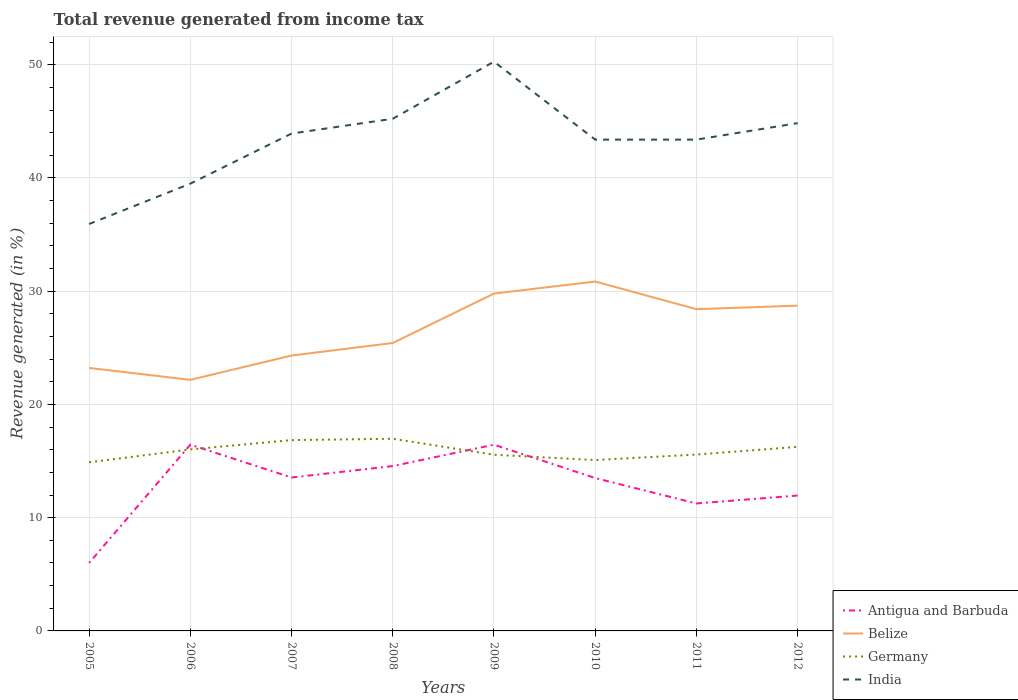How many different coloured lines are there?
Offer a terse response. 4. Does the line corresponding to India intersect with the line corresponding to Belize?
Provide a short and direct response. No. Across all years, what is the maximum total revenue generated in India?
Give a very brief answer. 35.93. In which year was the total revenue generated in Belize maximum?
Keep it short and to the point. 2006. What is the total total revenue generated in Antigua and Barbuda in the graph?
Your answer should be very brief. 2.29. What is the difference between the highest and the second highest total revenue generated in India?
Give a very brief answer. 14.34. What is the difference between the highest and the lowest total revenue generated in Antigua and Barbuda?
Offer a terse response. 5. How many lines are there?
Give a very brief answer. 4. How many years are there in the graph?
Ensure brevity in your answer.  8. Are the values on the major ticks of Y-axis written in scientific E-notation?
Give a very brief answer. No. Does the graph contain grids?
Your answer should be very brief. Yes. How many legend labels are there?
Give a very brief answer. 4. How are the legend labels stacked?
Offer a very short reply. Vertical. What is the title of the graph?
Make the answer very short. Total revenue generated from income tax. What is the label or title of the X-axis?
Provide a short and direct response. Years. What is the label or title of the Y-axis?
Offer a very short reply. Revenue generated (in %). What is the Revenue generated (in %) of Antigua and Barbuda in 2005?
Offer a terse response. 6.01. What is the Revenue generated (in %) in Belize in 2005?
Keep it short and to the point. 23.22. What is the Revenue generated (in %) in Germany in 2005?
Make the answer very short. 14.89. What is the Revenue generated (in %) of India in 2005?
Your answer should be compact. 35.93. What is the Revenue generated (in %) in Antigua and Barbuda in 2006?
Keep it short and to the point. 16.45. What is the Revenue generated (in %) in Belize in 2006?
Provide a short and direct response. 22.17. What is the Revenue generated (in %) in Germany in 2006?
Keep it short and to the point. 16.03. What is the Revenue generated (in %) in India in 2006?
Offer a terse response. 39.5. What is the Revenue generated (in %) in Antigua and Barbuda in 2007?
Your response must be concise. 13.55. What is the Revenue generated (in %) of Belize in 2007?
Offer a very short reply. 24.32. What is the Revenue generated (in %) in Germany in 2007?
Your response must be concise. 16.85. What is the Revenue generated (in %) of India in 2007?
Offer a very short reply. 43.92. What is the Revenue generated (in %) of Antigua and Barbuda in 2008?
Your answer should be compact. 14.56. What is the Revenue generated (in %) in Belize in 2008?
Offer a terse response. 25.43. What is the Revenue generated (in %) in Germany in 2008?
Make the answer very short. 16.97. What is the Revenue generated (in %) in India in 2008?
Keep it short and to the point. 45.23. What is the Revenue generated (in %) in Antigua and Barbuda in 2009?
Ensure brevity in your answer.  16.45. What is the Revenue generated (in %) of Belize in 2009?
Offer a very short reply. 29.79. What is the Revenue generated (in %) in Germany in 2009?
Your response must be concise. 15.56. What is the Revenue generated (in %) in India in 2009?
Ensure brevity in your answer.  50.27. What is the Revenue generated (in %) in Antigua and Barbuda in 2010?
Your answer should be compact. 13.5. What is the Revenue generated (in %) in Belize in 2010?
Make the answer very short. 30.85. What is the Revenue generated (in %) in Germany in 2010?
Your answer should be compact. 15.09. What is the Revenue generated (in %) in India in 2010?
Your answer should be compact. 43.38. What is the Revenue generated (in %) in Antigua and Barbuda in 2011?
Your answer should be very brief. 11.26. What is the Revenue generated (in %) in Belize in 2011?
Ensure brevity in your answer.  28.41. What is the Revenue generated (in %) of Germany in 2011?
Make the answer very short. 15.57. What is the Revenue generated (in %) in India in 2011?
Keep it short and to the point. 43.38. What is the Revenue generated (in %) of Antigua and Barbuda in 2012?
Your answer should be compact. 11.95. What is the Revenue generated (in %) of Belize in 2012?
Provide a succinct answer. 28.72. What is the Revenue generated (in %) in Germany in 2012?
Provide a succinct answer. 16.25. What is the Revenue generated (in %) in India in 2012?
Your response must be concise. 44.84. Across all years, what is the maximum Revenue generated (in %) of Antigua and Barbuda?
Provide a succinct answer. 16.45. Across all years, what is the maximum Revenue generated (in %) in Belize?
Ensure brevity in your answer.  30.85. Across all years, what is the maximum Revenue generated (in %) in Germany?
Offer a terse response. 16.97. Across all years, what is the maximum Revenue generated (in %) in India?
Provide a succinct answer. 50.27. Across all years, what is the minimum Revenue generated (in %) in Antigua and Barbuda?
Provide a short and direct response. 6.01. Across all years, what is the minimum Revenue generated (in %) in Belize?
Provide a succinct answer. 22.17. Across all years, what is the minimum Revenue generated (in %) of Germany?
Make the answer very short. 14.89. Across all years, what is the minimum Revenue generated (in %) of India?
Make the answer very short. 35.93. What is the total Revenue generated (in %) in Antigua and Barbuda in the graph?
Your response must be concise. 103.71. What is the total Revenue generated (in %) in Belize in the graph?
Make the answer very short. 212.92. What is the total Revenue generated (in %) of Germany in the graph?
Provide a succinct answer. 127.21. What is the total Revenue generated (in %) of India in the graph?
Ensure brevity in your answer.  346.46. What is the difference between the Revenue generated (in %) of Antigua and Barbuda in 2005 and that in 2006?
Your answer should be very brief. -10.44. What is the difference between the Revenue generated (in %) of Belize in 2005 and that in 2006?
Provide a succinct answer. 1.05. What is the difference between the Revenue generated (in %) in Germany in 2005 and that in 2006?
Ensure brevity in your answer.  -1.13. What is the difference between the Revenue generated (in %) of India in 2005 and that in 2006?
Provide a short and direct response. -3.56. What is the difference between the Revenue generated (in %) of Antigua and Barbuda in 2005 and that in 2007?
Your answer should be compact. -7.54. What is the difference between the Revenue generated (in %) in Belize in 2005 and that in 2007?
Your answer should be very brief. -1.1. What is the difference between the Revenue generated (in %) in Germany in 2005 and that in 2007?
Offer a terse response. -1.96. What is the difference between the Revenue generated (in %) of India in 2005 and that in 2007?
Offer a terse response. -7.99. What is the difference between the Revenue generated (in %) of Antigua and Barbuda in 2005 and that in 2008?
Ensure brevity in your answer.  -8.55. What is the difference between the Revenue generated (in %) of Belize in 2005 and that in 2008?
Your answer should be very brief. -2.21. What is the difference between the Revenue generated (in %) of Germany in 2005 and that in 2008?
Your answer should be very brief. -2.08. What is the difference between the Revenue generated (in %) in India in 2005 and that in 2008?
Give a very brief answer. -9.29. What is the difference between the Revenue generated (in %) in Antigua and Barbuda in 2005 and that in 2009?
Make the answer very short. -10.44. What is the difference between the Revenue generated (in %) in Belize in 2005 and that in 2009?
Keep it short and to the point. -6.57. What is the difference between the Revenue generated (in %) of Germany in 2005 and that in 2009?
Provide a succinct answer. -0.66. What is the difference between the Revenue generated (in %) of India in 2005 and that in 2009?
Provide a short and direct response. -14.34. What is the difference between the Revenue generated (in %) of Antigua and Barbuda in 2005 and that in 2010?
Offer a terse response. -7.49. What is the difference between the Revenue generated (in %) of Belize in 2005 and that in 2010?
Offer a very short reply. -7.63. What is the difference between the Revenue generated (in %) in Germany in 2005 and that in 2010?
Give a very brief answer. -0.2. What is the difference between the Revenue generated (in %) in India in 2005 and that in 2010?
Offer a terse response. -7.45. What is the difference between the Revenue generated (in %) of Antigua and Barbuda in 2005 and that in 2011?
Provide a short and direct response. -5.25. What is the difference between the Revenue generated (in %) of Belize in 2005 and that in 2011?
Your answer should be very brief. -5.19. What is the difference between the Revenue generated (in %) of Germany in 2005 and that in 2011?
Your response must be concise. -0.68. What is the difference between the Revenue generated (in %) of India in 2005 and that in 2011?
Ensure brevity in your answer.  -7.45. What is the difference between the Revenue generated (in %) in Antigua and Barbuda in 2005 and that in 2012?
Offer a very short reply. -5.95. What is the difference between the Revenue generated (in %) in Belize in 2005 and that in 2012?
Ensure brevity in your answer.  -5.5. What is the difference between the Revenue generated (in %) in Germany in 2005 and that in 2012?
Offer a very short reply. -1.36. What is the difference between the Revenue generated (in %) in India in 2005 and that in 2012?
Your answer should be compact. -8.91. What is the difference between the Revenue generated (in %) of Antigua and Barbuda in 2006 and that in 2007?
Keep it short and to the point. 2.9. What is the difference between the Revenue generated (in %) of Belize in 2006 and that in 2007?
Ensure brevity in your answer.  -2.15. What is the difference between the Revenue generated (in %) in Germany in 2006 and that in 2007?
Ensure brevity in your answer.  -0.83. What is the difference between the Revenue generated (in %) of India in 2006 and that in 2007?
Keep it short and to the point. -4.42. What is the difference between the Revenue generated (in %) in Antigua and Barbuda in 2006 and that in 2008?
Your answer should be very brief. 1.89. What is the difference between the Revenue generated (in %) of Belize in 2006 and that in 2008?
Give a very brief answer. -3.26. What is the difference between the Revenue generated (in %) in Germany in 2006 and that in 2008?
Offer a very short reply. -0.94. What is the difference between the Revenue generated (in %) of India in 2006 and that in 2008?
Your answer should be very brief. -5.73. What is the difference between the Revenue generated (in %) of Antigua and Barbuda in 2006 and that in 2009?
Keep it short and to the point. 0. What is the difference between the Revenue generated (in %) of Belize in 2006 and that in 2009?
Your answer should be very brief. -7.62. What is the difference between the Revenue generated (in %) in Germany in 2006 and that in 2009?
Your answer should be very brief. 0.47. What is the difference between the Revenue generated (in %) in India in 2006 and that in 2009?
Provide a short and direct response. -10.77. What is the difference between the Revenue generated (in %) of Antigua and Barbuda in 2006 and that in 2010?
Your answer should be very brief. 2.95. What is the difference between the Revenue generated (in %) of Belize in 2006 and that in 2010?
Keep it short and to the point. -8.68. What is the difference between the Revenue generated (in %) of Germany in 2006 and that in 2010?
Make the answer very short. 0.94. What is the difference between the Revenue generated (in %) of India in 2006 and that in 2010?
Your answer should be very brief. -3.89. What is the difference between the Revenue generated (in %) of Antigua and Barbuda in 2006 and that in 2011?
Your answer should be compact. 5.19. What is the difference between the Revenue generated (in %) in Belize in 2006 and that in 2011?
Give a very brief answer. -6.24. What is the difference between the Revenue generated (in %) in Germany in 2006 and that in 2011?
Provide a succinct answer. 0.45. What is the difference between the Revenue generated (in %) of India in 2006 and that in 2011?
Provide a succinct answer. -3.89. What is the difference between the Revenue generated (in %) of Antigua and Barbuda in 2006 and that in 2012?
Ensure brevity in your answer.  4.49. What is the difference between the Revenue generated (in %) of Belize in 2006 and that in 2012?
Make the answer very short. -6.55. What is the difference between the Revenue generated (in %) of Germany in 2006 and that in 2012?
Your response must be concise. -0.23. What is the difference between the Revenue generated (in %) in India in 2006 and that in 2012?
Keep it short and to the point. -5.34. What is the difference between the Revenue generated (in %) of Antigua and Barbuda in 2007 and that in 2008?
Your response must be concise. -1.01. What is the difference between the Revenue generated (in %) of Belize in 2007 and that in 2008?
Keep it short and to the point. -1.11. What is the difference between the Revenue generated (in %) in Germany in 2007 and that in 2008?
Your answer should be very brief. -0.12. What is the difference between the Revenue generated (in %) of India in 2007 and that in 2008?
Your answer should be compact. -1.31. What is the difference between the Revenue generated (in %) of Antigua and Barbuda in 2007 and that in 2009?
Make the answer very short. -2.9. What is the difference between the Revenue generated (in %) in Belize in 2007 and that in 2009?
Your response must be concise. -5.47. What is the difference between the Revenue generated (in %) of Germany in 2007 and that in 2009?
Keep it short and to the point. 1.29. What is the difference between the Revenue generated (in %) of India in 2007 and that in 2009?
Make the answer very short. -6.35. What is the difference between the Revenue generated (in %) of Antigua and Barbuda in 2007 and that in 2010?
Offer a very short reply. 0.05. What is the difference between the Revenue generated (in %) of Belize in 2007 and that in 2010?
Offer a terse response. -6.53. What is the difference between the Revenue generated (in %) in Germany in 2007 and that in 2010?
Make the answer very short. 1.76. What is the difference between the Revenue generated (in %) of India in 2007 and that in 2010?
Provide a succinct answer. 0.54. What is the difference between the Revenue generated (in %) in Antigua and Barbuda in 2007 and that in 2011?
Provide a succinct answer. 2.29. What is the difference between the Revenue generated (in %) of Belize in 2007 and that in 2011?
Your response must be concise. -4.09. What is the difference between the Revenue generated (in %) in Germany in 2007 and that in 2011?
Your response must be concise. 1.28. What is the difference between the Revenue generated (in %) of India in 2007 and that in 2011?
Your answer should be very brief. 0.54. What is the difference between the Revenue generated (in %) of Antigua and Barbuda in 2007 and that in 2012?
Your answer should be compact. 1.59. What is the difference between the Revenue generated (in %) in Belize in 2007 and that in 2012?
Give a very brief answer. -4.41. What is the difference between the Revenue generated (in %) of Germany in 2007 and that in 2012?
Provide a succinct answer. 0.6. What is the difference between the Revenue generated (in %) of India in 2007 and that in 2012?
Provide a succinct answer. -0.92. What is the difference between the Revenue generated (in %) of Antigua and Barbuda in 2008 and that in 2009?
Provide a short and direct response. -1.89. What is the difference between the Revenue generated (in %) of Belize in 2008 and that in 2009?
Make the answer very short. -4.36. What is the difference between the Revenue generated (in %) of Germany in 2008 and that in 2009?
Provide a short and direct response. 1.41. What is the difference between the Revenue generated (in %) in India in 2008 and that in 2009?
Offer a terse response. -5.04. What is the difference between the Revenue generated (in %) of Antigua and Barbuda in 2008 and that in 2010?
Your response must be concise. 1.06. What is the difference between the Revenue generated (in %) of Belize in 2008 and that in 2010?
Ensure brevity in your answer.  -5.43. What is the difference between the Revenue generated (in %) in Germany in 2008 and that in 2010?
Offer a very short reply. 1.88. What is the difference between the Revenue generated (in %) in India in 2008 and that in 2010?
Provide a short and direct response. 1.84. What is the difference between the Revenue generated (in %) in Antigua and Barbuda in 2008 and that in 2011?
Your answer should be very brief. 3.3. What is the difference between the Revenue generated (in %) of Belize in 2008 and that in 2011?
Offer a terse response. -2.98. What is the difference between the Revenue generated (in %) of Germany in 2008 and that in 2011?
Your answer should be compact. 1.4. What is the difference between the Revenue generated (in %) in India in 2008 and that in 2011?
Your answer should be very brief. 1.84. What is the difference between the Revenue generated (in %) in Antigua and Barbuda in 2008 and that in 2012?
Your answer should be very brief. 2.6. What is the difference between the Revenue generated (in %) of Belize in 2008 and that in 2012?
Offer a very short reply. -3.3. What is the difference between the Revenue generated (in %) of Germany in 2008 and that in 2012?
Your response must be concise. 0.72. What is the difference between the Revenue generated (in %) of India in 2008 and that in 2012?
Keep it short and to the point. 0.39. What is the difference between the Revenue generated (in %) in Antigua and Barbuda in 2009 and that in 2010?
Offer a very short reply. 2.95. What is the difference between the Revenue generated (in %) in Belize in 2009 and that in 2010?
Your response must be concise. -1.06. What is the difference between the Revenue generated (in %) of Germany in 2009 and that in 2010?
Your answer should be very brief. 0.47. What is the difference between the Revenue generated (in %) in India in 2009 and that in 2010?
Keep it short and to the point. 6.89. What is the difference between the Revenue generated (in %) of Antigua and Barbuda in 2009 and that in 2011?
Ensure brevity in your answer.  5.19. What is the difference between the Revenue generated (in %) in Belize in 2009 and that in 2011?
Provide a short and direct response. 1.38. What is the difference between the Revenue generated (in %) in Germany in 2009 and that in 2011?
Provide a succinct answer. -0.02. What is the difference between the Revenue generated (in %) in India in 2009 and that in 2011?
Give a very brief answer. 6.89. What is the difference between the Revenue generated (in %) in Antigua and Barbuda in 2009 and that in 2012?
Provide a succinct answer. 4.49. What is the difference between the Revenue generated (in %) in Belize in 2009 and that in 2012?
Make the answer very short. 1.07. What is the difference between the Revenue generated (in %) in Germany in 2009 and that in 2012?
Give a very brief answer. -0.7. What is the difference between the Revenue generated (in %) of India in 2009 and that in 2012?
Provide a succinct answer. 5.43. What is the difference between the Revenue generated (in %) of Antigua and Barbuda in 2010 and that in 2011?
Offer a very short reply. 2.24. What is the difference between the Revenue generated (in %) of Belize in 2010 and that in 2011?
Your response must be concise. 2.44. What is the difference between the Revenue generated (in %) of Germany in 2010 and that in 2011?
Make the answer very short. -0.48. What is the difference between the Revenue generated (in %) of India in 2010 and that in 2011?
Offer a terse response. 0. What is the difference between the Revenue generated (in %) of Antigua and Barbuda in 2010 and that in 2012?
Offer a terse response. 1.54. What is the difference between the Revenue generated (in %) of Belize in 2010 and that in 2012?
Provide a short and direct response. 2.13. What is the difference between the Revenue generated (in %) of Germany in 2010 and that in 2012?
Your answer should be very brief. -1.16. What is the difference between the Revenue generated (in %) of India in 2010 and that in 2012?
Keep it short and to the point. -1.45. What is the difference between the Revenue generated (in %) in Antigua and Barbuda in 2011 and that in 2012?
Make the answer very short. -0.7. What is the difference between the Revenue generated (in %) in Belize in 2011 and that in 2012?
Give a very brief answer. -0.31. What is the difference between the Revenue generated (in %) of Germany in 2011 and that in 2012?
Make the answer very short. -0.68. What is the difference between the Revenue generated (in %) in India in 2011 and that in 2012?
Provide a short and direct response. -1.45. What is the difference between the Revenue generated (in %) in Antigua and Barbuda in 2005 and the Revenue generated (in %) in Belize in 2006?
Offer a very short reply. -16.17. What is the difference between the Revenue generated (in %) in Antigua and Barbuda in 2005 and the Revenue generated (in %) in Germany in 2006?
Give a very brief answer. -10.02. What is the difference between the Revenue generated (in %) in Antigua and Barbuda in 2005 and the Revenue generated (in %) in India in 2006?
Provide a short and direct response. -33.49. What is the difference between the Revenue generated (in %) of Belize in 2005 and the Revenue generated (in %) of Germany in 2006?
Your answer should be very brief. 7.2. What is the difference between the Revenue generated (in %) of Belize in 2005 and the Revenue generated (in %) of India in 2006?
Your answer should be compact. -16.28. What is the difference between the Revenue generated (in %) in Germany in 2005 and the Revenue generated (in %) in India in 2006?
Give a very brief answer. -24.61. What is the difference between the Revenue generated (in %) of Antigua and Barbuda in 2005 and the Revenue generated (in %) of Belize in 2007?
Offer a terse response. -18.31. What is the difference between the Revenue generated (in %) of Antigua and Barbuda in 2005 and the Revenue generated (in %) of Germany in 2007?
Provide a short and direct response. -10.85. What is the difference between the Revenue generated (in %) of Antigua and Barbuda in 2005 and the Revenue generated (in %) of India in 2007?
Keep it short and to the point. -37.92. What is the difference between the Revenue generated (in %) of Belize in 2005 and the Revenue generated (in %) of Germany in 2007?
Ensure brevity in your answer.  6.37. What is the difference between the Revenue generated (in %) in Belize in 2005 and the Revenue generated (in %) in India in 2007?
Provide a short and direct response. -20.7. What is the difference between the Revenue generated (in %) of Germany in 2005 and the Revenue generated (in %) of India in 2007?
Provide a short and direct response. -29.03. What is the difference between the Revenue generated (in %) of Antigua and Barbuda in 2005 and the Revenue generated (in %) of Belize in 2008?
Give a very brief answer. -19.42. What is the difference between the Revenue generated (in %) in Antigua and Barbuda in 2005 and the Revenue generated (in %) in Germany in 2008?
Provide a short and direct response. -10.96. What is the difference between the Revenue generated (in %) in Antigua and Barbuda in 2005 and the Revenue generated (in %) in India in 2008?
Offer a terse response. -39.22. What is the difference between the Revenue generated (in %) in Belize in 2005 and the Revenue generated (in %) in Germany in 2008?
Your response must be concise. 6.25. What is the difference between the Revenue generated (in %) of Belize in 2005 and the Revenue generated (in %) of India in 2008?
Keep it short and to the point. -22.01. What is the difference between the Revenue generated (in %) in Germany in 2005 and the Revenue generated (in %) in India in 2008?
Your response must be concise. -30.34. What is the difference between the Revenue generated (in %) in Antigua and Barbuda in 2005 and the Revenue generated (in %) in Belize in 2009?
Ensure brevity in your answer.  -23.79. What is the difference between the Revenue generated (in %) of Antigua and Barbuda in 2005 and the Revenue generated (in %) of Germany in 2009?
Your answer should be very brief. -9.55. What is the difference between the Revenue generated (in %) in Antigua and Barbuda in 2005 and the Revenue generated (in %) in India in 2009?
Give a very brief answer. -44.27. What is the difference between the Revenue generated (in %) in Belize in 2005 and the Revenue generated (in %) in Germany in 2009?
Your response must be concise. 7.66. What is the difference between the Revenue generated (in %) of Belize in 2005 and the Revenue generated (in %) of India in 2009?
Ensure brevity in your answer.  -27.05. What is the difference between the Revenue generated (in %) of Germany in 2005 and the Revenue generated (in %) of India in 2009?
Provide a short and direct response. -35.38. What is the difference between the Revenue generated (in %) in Antigua and Barbuda in 2005 and the Revenue generated (in %) in Belize in 2010?
Offer a very short reply. -24.85. What is the difference between the Revenue generated (in %) in Antigua and Barbuda in 2005 and the Revenue generated (in %) in Germany in 2010?
Offer a very short reply. -9.08. What is the difference between the Revenue generated (in %) of Antigua and Barbuda in 2005 and the Revenue generated (in %) of India in 2010?
Make the answer very short. -37.38. What is the difference between the Revenue generated (in %) in Belize in 2005 and the Revenue generated (in %) in Germany in 2010?
Offer a very short reply. 8.13. What is the difference between the Revenue generated (in %) of Belize in 2005 and the Revenue generated (in %) of India in 2010?
Ensure brevity in your answer.  -20.16. What is the difference between the Revenue generated (in %) of Germany in 2005 and the Revenue generated (in %) of India in 2010?
Offer a terse response. -28.49. What is the difference between the Revenue generated (in %) in Antigua and Barbuda in 2005 and the Revenue generated (in %) in Belize in 2011?
Ensure brevity in your answer.  -22.41. What is the difference between the Revenue generated (in %) in Antigua and Barbuda in 2005 and the Revenue generated (in %) in Germany in 2011?
Keep it short and to the point. -9.57. What is the difference between the Revenue generated (in %) in Antigua and Barbuda in 2005 and the Revenue generated (in %) in India in 2011?
Give a very brief answer. -37.38. What is the difference between the Revenue generated (in %) of Belize in 2005 and the Revenue generated (in %) of Germany in 2011?
Provide a short and direct response. 7.65. What is the difference between the Revenue generated (in %) of Belize in 2005 and the Revenue generated (in %) of India in 2011?
Make the answer very short. -20.16. What is the difference between the Revenue generated (in %) of Germany in 2005 and the Revenue generated (in %) of India in 2011?
Provide a short and direct response. -28.49. What is the difference between the Revenue generated (in %) of Antigua and Barbuda in 2005 and the Revenue generated (in %) of Belize in 2012?
Provide a short and direct response. -22.72. What is the difference between the Revenue generated (in %) in Antigua and Barbuda in 2005 and the Revenue generated (in %) in Germany in 2012?
Offer a terse response. -10.25. What is the difference between the Revenue generated (in %) of Antigua and Barbuda in 2005 and the Revenue generated (in %) of India in 2012?
Your response must be concise. -38.83. What is the difference between the Revenue generated (in %) of Belize in 2005 and the Revenue generated (in %) of Germany in 2012?
Provide a short and direct response. 6.97. What is the difference between the Revenue generated (in %) of Belize in 2005 and the Revenue generated (in %) of India in 2012?
Make the answer very short. -21.62. What is the difference between the Revenue generated (in %) in Germany in 2005 and the Revenue generated (in %) in India in 2012?
Your response must be concise. -29.95. What is the difference between the Revenue generated (in %) of Antigua and Barbuda in 2006 and the Revenue generated (in %) of Belize in 2007?
Your response must be concise. -7.87. What is the difference between the Revenue generated (in %) in Antigua and Barbuda in 2006 and the Revenue generated (in %) in Germany in 2007?
Make the answer very short. -0.4. What is the difference between the Revenue generated (in %) of Antigua and Barbuda in 2006 and the Revenue generated (in %) of India in 2007?
Make the answer very short. -27.47. What is the difference between the Revenue generated (in %) in Belize in 2006 and the Revenue generated (in %) in Germany in 2007?
Make the answer very short. 5.32. What is the difference between the Revenue generated (in %) in Belize in 2006 and the Revenue generated (in %) in India in 2007?
Provide a short and direct response. -21.75. What is the difference between the Revenue generated (in %) of Germany in 2006 and the Revenue generated (in %) of India in 2007?
Provide a succinct answer. -27.9. What is the difference between the Revenue generated (in %) of Antigua and Barbuda in 2006 and the Revenue generated (in %) of Belize in 2008?
Offer a terse response. -8.98. What is the difference between the Revenue generated (in %) of Antigua and Barbuda in 2006 and the Revenue generated (in %) of Germany in 2008?
Ensure brevity in your answer.  -0.52. What is the difference between the Revenue generated (in %) in Antigua and Barbuda in 2006 and the Revenue generated (in %) in India in 2008?
Offer a terse response. -28.78. What is the difference between the Revenue generated (in %) of Belize in 2006 and the Revenue generated (in %) of Germany in 2008?
Give a very brief answer. 5.2. What is the difference between the Revenue generated (in %) in Belize in 2006 and the Revenue generated (in %) in India in 2008?
Your response must be concise. -23.06. What is the difference between the Revenue generated (in %) in Germany in 2006 and the Revenue generated (in %) in India in 2008?
Your response must be concise. -29.2. What is the difference between the Revenue generated (in %) of Antigua and Barbuda in 2006 and the Revenue generated (in %) of Belize in 2009?
Ensure brevity in your answer.  -13.34. What is the difference between the Revenue generated (in %) of Antigua and Barbuda in 2006 and the Revenue generated (in %) of Germany in 2009?
Give a very brief answer. 0.89. What is the difference between the Revenue generated (in %) in Antigua and Barbuda in 2006 and the Revenue generated (in %) in India in 2009?
Provide a succinct answer. -33.82. What is the difference between the Revenue generated (in %) of Belize in 2006 and the Revenue generated (in %) of Germany in 2009?
Provide a short and direct response. 6.61. What is the difference between the Revenue generated (in %) in Belize in 2006 and the Revenue generated (in %) in India in 2009?
Offer a very short reply. -28.1. What is the difference between the Revenue generated (in %) in Germany in 2006 and the Revenue generated (in %) in India in 2009?
Offer a very short reply. -34.25. What is the difference between the Revenue generated (in %) in Antigua and Barbuda in 2006 and the Revenue generated (in %) in Belize in 2010?
Make the answer very short. -14.41. What is the difference between the Revenue generated (in %) of Antigua and Barbuda in 2006 and the Revenue generated (in %) of Germany in 2010?
Your answer should be compact. 1.36. What is the difference between the Revenue generated (in %) of Antigua and Barbuda in 2006 and the Revenue generated (in %) of India in 2010?
Provide a succinct answer. -26.94. What is the difference between the Revenue generated (in %) in Belize in 2006 and the Revenue generated (in %) in Germany in 2010?
Ensure brevity in your answer.  7.08. What is the difference between the Revenue generated (in %) of Belize in 2006 and the Revenue generated (in %) of India in 2010?
Provide a succinct answer. -21.21. What is the difference between the Revenue generated (in %) in Germany in 2006 and the Revenue generated (in %) in India in 2010?
Your answer should be very brief. -27.36. What is the difference between the Revenue generated (in %) in Antigua and Barbuda in 2006 and the Revenue generated (in %) in Belize in 2011?
Give a very brief answer. -11.96. What is the difference between the Revenue generated (in %) in Antigua and Barbuda in 2006 and the Revenue generated (in %) in Germany in 2011?
Make the answer very short. 0.87. What is the difference between the Revenue generated (in %) in Antigua and Barbuda in 2006 and the Revenue generated (in %) in India in 2011?
Your answer should be very brief. -26.94. What is the difference between the Revenue generated (in %) of Belize in 2006 and the Revenue generated (in %) of Germany in 2011?
Provide a succinct answer. 6.6. What is the difference between the Revenue generated (in %) of Belize in 2006 and the Revenue generated (in %) of India in 2011?
Offer a very short reply. -21.21. What is the difference between the Revenue generated (in %) in Germany in 2006 and the Revenue generated (in %) in India in 2011?
Ensure brevity in your answer.  -27.36. What is the difference between the Revenue generated (in %) of Antigua and Barbuda in 2006 and the Revenue generated (in %) of Belize in 2012?
Your answer should be very brief. -12.28. What is the difference between the Revenue generated (in %) of Antigua and Barbuda in 2006 and the Revenue generated (in %) of Germany in 2012?
Give a very brief answer. 0.19. What is the difference between the Revenue generated (in %) of Antigua and Barbuda in 2006 and the Revenue generated (in %) of India in 2012?
Offer a very short reply. -28.39. What is the difference between the Revenue generated (in %) of Belize in 2006 and the Revenue generated (in %) of Germany in 2012?
Your response must be concise. 5.92. What is the difference between the Revenue generated (in %) of Belize in 2006 and the Revenue generated (in %) of India in 2012?
Keep it short and to the point. -22.67. What is the difference between the Revenue generated (in %) in Germany in 2006 and the Revenue generated (in %) in India in 2012?
Your response must be concise. -28.81. What is the difference between the Revenue generated (in %) in Antigua and Barbuda in 2007 and the Revenue generated (in %) in Belize in 2008?
Offer a terse response. -11.88. What is the difference between the Revenue generated (in %) of Antigua and Barbuda in 2007 and the Revenue generated (in %) of Germany in 2008?
Give a very brief answer. -3.42. What is the difference between the Revenue generated (in %) of Antigua and Barbuda in 2007 and the Revenue generated (in %) of India in 2008?
Keep it short and to the point. -31.68. What is the difference between the Revenue generated (in %) in Belize in 2007 and the Revenue generated (in %) in Germany in 2008?
Provide a short and direct response. 7.35. What is the difference between the Revenue generated (in %) of Belize in 2007 and the Revenue generated (in %) of India in 2008?
Offer a terse response. -20.91. What is the difference between the Revenue generated (in %) in Germany in 2007 and the Revenue generated (in %) in India in 2008?
Your answer should be compact. -28.38. What is the difference between the Revenue generated (in %) of Antigua and Barbuda in 2007 and the Revenue generated (in %) of Belize in 2009?
Your answer should be compact. -16.24. What is the difference between the Revenue generated (in %) in Antigua and Barbuda in 2007 and the Revenue generated (in %) in Germany in 2009?
Keep it short and to the point. -2.01. What is the difference between the Revenue generated (in %) of Antigua and Barbuda in 2007 and the Revenue generated (in %) of India in 2009?
Give a very brief answer. -36.72. What is the difference between the Revenue generated (in %) of Belize in 2007 and the Revenue generated (in %) of Germany in 2009?
Your answer should be compact. 8.76. What is the difference between the Revenue generated (in %) of Belize in 2007 and the Revenue generated (in %) of India in 2009?
Your response must be concise. -25.95. What is the difference between the Revenue generated (in %) in Germany in 2007 and the Revenue generated (in %) in India in 2009?
Give a very brief answer. -33.42. What is the difference between the Revenue generated (in %) of Antigua and Barbuda in 2007 and the Revenue generated (in %) of Belize in 2010?
Offer a terse response. -17.3. What is the difference between the Revenue generated (in %) in Antigua and Barbuda in 2007 and the Revenue generated (in %) in Germany in 2010?
Provide a succinct answer. -1.54. What is the difference between the Revenue generated (in %) in Antigua and Barbuda in 2007 and the Revenue generated (in %) in India in 2010?
Provide a succinct answer. -29.84. What is the difference between the Revenue generated (in %) of Belize in 2007 and the Revenue generated (in %) of Germany in 2010?
Offer a terse response. 9.23. What is the difference between the Revenue generated (in %) in Belize in 2007 and the Revenue generated (in %) in India in 2010?
Your answer should be very brief. -19.07. What is the difference between the Revenue generated (in %) of Germany in 2007 and the Revenue generated (in %) of India in 2010?
Make the answer very short. -26.53. What is the difference between the Revenue generated (in %) in Antigua and Barbuda in 2007 and the Revenue generated (in %) in Belize in 2011?
Provide a short and direct response. -14.86. What is the difference between the Revenue generated (in %) of Antigua and Barbuda in 2007 and the Revenue generated (in %) of Germany in 2011?
Make the answer very short. -2.03. What is the difference between the Revenue generated (in %) of Antigua and Barbuda in 2007 and the Revenue generated (in %) of India in 2011?
Keep it short and to the point. -29.84. What is the difference between the Revenue generated (in %) in Belize in 2007 and the Revenue generated (in %) in Germany in 2011?
Provide a succinct answer. 8.74. What is the difference between the Revenue generated (in %) in Belize in 2007 and the Revenue generated (in %) in India in 2011?
Offer a very short reply. -19.07. What is the difference between the Revenue generated (in %) of Germany in 2007 and the Revenue generated (in %) of India in 2011?
Provide a short and direct response. -26.53. What is the difference between the Revenue generated (in %) in Antigua and Barbuda in 2007 and the Revenue generated (in %) in Belize in 2012?
Provide a short and direct response. -15.18. What is the difference between the Revenue generated (in %) of Antigua and Barbuda in 2007 and the Revenue generated (in %) of Germany in 2012?
Provide a succinct answer. -2.7. What is the difference between the Revenue generated (in %) of Antigua and Barbuda in 2007 and the Revenue generated (in %) of India in 2012?
Your response must be concise. -31.29. What is the difference between the Revenue generated (in %) of Belize in 2007 and the Revenue generated (in %) of Germany in 2012?
Offer a very short reply. 8.06. What is the difference between the Revenue generated (in %) of Belize in 2007 and the Revenue generated (in %) of India in 2012?
Offer a very short reply. -20.52. What is the difference between the Revenue generated (in %) in Germany in 2007 and the Revenue generated (in %) in India in 2012?
Provide a short and direct response. -27.99. What is the difference between the Revenue generated (in %) of Antigua and Barbuda in 2008 and the Revenue generated (in %) of Belize in 2009?
Ensure brevity in your answer.  -15.23. What is the difference between the Revenue generated (in %) in Antigua and Barbuda in 2008 and the Revenue generated (in %) in Germany in 2009?
Ensure brevity in your answer.  -1. What is the difference between the Revenue generated (in %) of Antigua and Barbuda in 2008 and the Revenue generated (in %) of India in 2009?
Provide a short and direct response. -35.71. What is the difference between the Revenue generated (in %) in Belize in 2008 and the Revenue generated (in %) in Germany in 2009?
Give a very brief answer. 9.87. What is the difference between the Revenue generated (in %) of Belize in 2008 and the Revenue generated (in %) of India in 2009?
Give a very brief answer. -24.84. What is the difference between the Revenue generated (in %) of Germany in 2008 and the Revenue generated (in %) of India in 2009?
Ensure brevity in your answer.  -33.3. What is the difference between the Revenue generated (in %) in Antigua and Barbuda in 2008 and the Revenue generated (in %) in Belize in 2010?
Your answer should be compact. -16.3. What is the difference between the Revenue generated (in %) of Antigua and Barbuda in 2008 and the Revenue generated (in %) of Germany in 2010?
Your response must be concise. -0.53. What is the difference between the Revenue generated (in %) of Antigua and Barbuda in 2008 and the Revenue generated (in %) of India in 2010?
Your answer should be compact. -28.83. What is the difference between the Revenue generated (in %) of Belize in 2008 and the Revenue generated (in %) of Germany in 2010?
Your answer should be compact. 10.34. What is the difference between the Revenue generated (in %) of Belize in 2008 and the Revenue generated (in %) of India in 2010?
Offer a very short reply. -17.96. What is the difference between the Revenue generated (in %) in Germany in 2008 and the Revenue generated (in %) in India in 2010?
Your answer should be very brief. -26.41. What is the difference between the Revenue generated (in %) of Antigua and Barbuda in 2008 and the Revenue generated (in %) of Belize in 2011?
Offer a terse response. -13.86. What is the difference between the Revenue generated (in %) of Antigua and Barbuda in 2008 and the Revenue generated (in %) of Germany in 2011?
Your answer should be compact. -1.02. What is the difference between the Revenue generated (in %) of Antigua and Barbuda in 2008 and the Revenue generated (in %) of India in 2011?
Offer a terse response. -28.83. What is the difference between the Revenue generated (in %) of Belize in 2008 and the Revenue generated (in %) of Germany in 2011?
Your answer should be compact. 9.85. What is the difference between the Revenue generated (in %) of Belize in 2008 and the Revenue generated (in %) of India in 2011?
Your answer should be very brief. -17.96. What is the difference between the Revenue generated (in %) in Germany in 2008 and the Revenue generated (in %) in India in 2011?
Offer a terse response. -26.41. What is the difference between the Revenue generated (in %) of Antigua and Barbuda in 2008 and the Revenue generated (in %) of Belize in 2012?
Ensure brevity in your answer.  -14.17. What is the difference between the Revenue generated (in %) in Antigua and Barbuda in 2008 and the Revenue generated (in %) in Germany in 2012?
Offer a terse response. -1.7. What is the difference between the Revenue generated (in %) in Antigua and Barbuda in 2008 and the Revenue generated (in %) in India in 2012?
Your response must be concise. -30.28. What is the difference between the Revenue generated (in %) in Belize in 2008 and the Revenue generated (in %) in Germany in 2012?
Your answer should be very brief. 9.17. What is the difference between the Revenue generated (in %) of Belize in 2008 and the Revenue generated (in %) of India in 2012?
Ensure brevity in your answer.  -19.41. What is the difference between the Revenue generated (in %) of Germany in 2008 and the Revenue generated (in %) of India in 2012?
Provide a short and direct response. -27.87. What is the difference between the Revenue generated (in %) in Antigua and Barbuda in 2009 and the Revenue generated (in %) in Belize in 2010?
Offer a terse response. -14.41. What is the difference between the Revenue generated (in %) in Antigua and Barbuda in 2009 and the Revenue generated (in %) in Germany in 2010?
Provide a short and direct response. 1.36. What is the difference between the Revenue generated (in %) in Antigua and Barbuda in 2009 and the Revenue generated (in %) in India in 2010?
Ensure brevity in your answer.  -26.94. What is the difference between the Revenue generated (in %) in Belize in 2009 and the Revenue generated (in %) in Germany in 2010?
Keep it short and to the point. 14.7. What is the difference between the Revenue generated (in %) in Belize in 2009 and the Revenue generated (in %) in India in 2010?
Your answer should be very brief. -13.59. What is the difference between the Revenue generated (in %) of Germany in 2009 and the Revenue generated (in %) of India in 2010?
Your answer should be compact. -27.83. What is the difference between the Revenue generated (in %) in Antigua and Barbuda in 2009 and the Revenue generated (in %) in Belize in 2011?
Offer a very short reply. -11.97. What is the difference between the Revenue generated (in %) of Antigua and Barbuda in 2009 and the Revenue generated (in %) of Germany in 2011?
Keep it short and to the point. 0.87. What is the difference between the Revenue generated (in %) of Antigua and Barbuda in 2009 and the Revenue generated (in %) of India in 2011?
Your answer should be very brief. -26.94. What is the difference between the Revenue generated (in %) of Belize in 2009 and the Revenue generated (in %) of Germany in 2011?
Provide a short and direct response. 14.22. What is the difference between the Revenue generated (in %) of Belize in 2009 and the Revenue generated (in %) of India in 2011?
Offer a very short reply. -13.59. What is the difference between the Revenue generated (in %) in Germany in 2009 and the Revenue generated (in %) in India in 2011?
Your answer should be compact. -27.83. What is the difference between the Revenue generated (in %) of Antigua and Barbuda in 2009 and the Revenue generated (in %) of Belize in 2012?
Provide a short and direct response. -12.28. What is the difference between the Revenue generated (in %) of Antigua and Barbuda in 2009 and the Revenue generated (in %) of Germany in 2012?
Make the answer very short. 0.19. What is the difference between the Revenue generated (in %) of Antigua and Barbuda in 2009 and the Revenue generated (in %) of India in 2012?
Keep it short and to the point. -28.39. What is the difference between the Revenue generated (in %) in Belize in 2009 and the Revenue generated (in %) in Germany in 2012?
Provide a succinct answer. 13.54. What is the difference between the Revenue generated (in %) in Belize in 2009 and the Revenue generated (in %) in India in 2012?
Make the answer very short. -15.05. What is the difference between the Revenue generated (in %) of Germany in 2009 and the Revenue generated (in %) of India in 2012?
Your answer should be very brief. -29.28. What is the difference between the Revenue generated (in %) of Antigua and Barbuda in 2010 and the Revenue generated (in %) of Belize in 2011?
Provide a succinct answer. -14.91. What is the difference between the Revenue generated (in %) in Antigua and Barbuda in 2010 and the Revenue generated (in %) in Germany in 2011?
Ensure brevity in your answer.  -2.08. What is the difference between the Revenue generated (in %) in Antigua and Barbuda in 2010 and the Revenue generated (in %) in India in 2011?
Provide a short and direct response. -29.89. What is the difference between the Revenue generated (in %) of Belize in 2010 and the Revenue generated (in %) of Germany in 2011?
Offer a very short reply. 15.28. What is the difference between the Revenue generated (in %) of Belize in 2010 and the Revenue generated (in %) of India in 2011?
Offer a very short reply. -12.53. What is the difference between the Revenue generated (in %) in Germany in 2010 and the Revenue generated (in %) in India in 2011?
Offer a terse response. -28.29. What is the difference between the Revenue generated (in %) in Antigua and Barbuda in 2010 and the Revenue generated (in %) in Belize in 2012?
Provide a short and direct response. -15.23. What is the difference between the Revenue generated (in %) of Antigua and Barbuda in 2010 and the Revenue generated (in %) of Germany in 2012?
Keep it short and to the point. -2.75. What is the difference between the Revenue generated (in %) of Antigua and Barbuda in 2010 and the Revenue generated (in %) of India in 2012?
Provide a short and direct response. -31.34. What is the difference between the Revenue generated (in %) of Belize in 2010 and the Revenue generated (in %) of Germany in 2012?
Provide a short and direct response. 14.6. What is the difference between the Revenue generated (in %) of Belize in 2010 and the Revenue generated (in %) of India in 2012?
Your answer should be very brief. -13.99. What is the difference between the Revenue generated (in %) in Germany in 2010 and the Revenue generated (in %) in India in 2012?
Offer a very short reply. -29.75. What is the difference between the Revenue generated (in %) in Antigua and Barbuda in 2011 and the Revenue generated (in %) in Belize in 2012?
Your answer should be very brief. -17.47. What is the difference between the Revenue generated (in %) of Antigua and Barbuda in 2011 and the Revenue generated (in %) of Germany in 2012?
Ensure brevity in your answer.  -5. What is the difference between the Revenue generated (in %) in Antigua and Barbuda in 2011 and the Revenue generated (in %) in India in 2012?
Your answer should be very brief. -33.58. What is the difference between the Revenue generated (in %) of Belize in 2011 and the Revenue generated (in %) of Germany in 2012?
Provide a succinct answer. 12.16. What is the difference between the Revenue generated (in %) of Belize in 2011 and the Revenue generated (in %) of India in 2012?
Offer a very short reply. -16.43. What is the difference between the Revenue generated (in %) in Germany in 2011 and the Revenue generated (in %) in India in 2012?
Keep it short and to the point. -29.26. What is the average Revenue generated (in %) in Antigua and Barbuda per year?
Provide a succinct answer. 12.96. What is the average Revenue generated (in %) in Belize per year?
Your answer should be compact. 26.62. What is the average Revenue generated (in %) of Germany per year?
Give a very brief answer. 15.9. What is the average Revenue generated (in %) of India per year?
Offer a terse response. 43.31. In the year 2005, what is the difference between the Revenue generated (in %) of Antigua and Barbuda and Revenue generated (in %) of Belize?
Ensure brevity in your answer.  -17.22. In the year 2005, what is the difference between the Revenue generated (in %) of Antigua and Barbuda and Revenue generated (in %) of Germany?
Provide a short and direct response. -8.89. In the year 2005, what is the difference between the Revenue generated (in %) of Antigua and Barbuda and Revenue generated (in %) of India?
Offer a very short reply. -29.93. In the year 2005, what is the difference between the Revenue generated (in %) of Belize and Revenue generated (in %) of Germany?
Offer a terse response. 8.33. In the year 2005, what is the difference between the Revenue generated (in %) in Belize and Revenue generated (in %) in India?
Provide a short and direct response. -12.71. In the year 2005, what is the difference between the Revenue generated (in %) of Germany and Revenue generated (in %) of India?
Offer a terse response. -21.04. In the year 2006, what is the difference between the Revenue generated (in %) of Antigua and Barbuda and Revenue generated (in %) of Belize?
Provide a succinct answer. -5.72. In the year 2006, what is the difference between the Revenue generated (in %) in Antigua and Barbuda and Revenue generated (in %) in Germany?
Your answer should be very brief. 0.42. In the year 2006, what is the difference between the Revenue generated (in %) in Antigua and Barbuda and Revenue generated (in %) in India?
Your answer should be compact. -23.05. In the year 2006, what is the difference between the Revenue generated (in %) in Belize and Revenue generated (in %) in Germany?
Offer a very short reply. 6.15. In the year 2006, what is the difference between the Revenue generated (in %) in Belize and Revenue generated (in %) in India?
Your answer should be compact. -17.33. In the year 2006, what is the difference between the Revenue generated (in %) in Germany and Revenue generated (in %) in India?
Offer a terse response. -23.47. In the year 2007, what is the difference between the Revenue generated (in %) of Antigua and Barbuda and Revenue generated (in %) of Belize?
Make the answer very short. -10.77. In the year 2007, what is the difference between the Revenue generated (in %) of Antigua and Barbuda and Revenue generated (in %) of Germany?
Make the answer very short. -3.3. In the year 2007, what is the difference between the Revenue generated (in %) of Antigua and Barbuda and Revenue generated (in %) of India?
Your answer should be compact. -30.37. In the year 2007, what is the difference between the Revenue generated (in %) of Belize and Revenue generated (in %) of Germany?
Your answer should be very brief. 7.47. In the year 2007, what is the difference between the Revenue generated (in %) in Belize and Revenue generated (in %) in India?
Your response must be concise. -19.6. In the year 2007, what is the difference between the Revenue generated (in %) of Germany and Revenue generated (in %) of India?
Give a very brief answer. -27.07. In the year 2008, what is the difference between the Revenue generated (in %) of Antigua and Barbuda and Revenue generated (in %) of Belize?
Offer a terse response. -10.87. In the year 2008, what is the difference between the Revenue generated (in %) in Antigua and Barbuda and Revenue generated (in %) in Germany?
Give a very brief answer. -2.41. In the year 2008, what is the difference between the Revenue generated (in %) of Antigua and Barbuda and Revenue generated (in %) of India?
Make the answer very short. -30.67. In the year 2008, what is the difference between the Revenue generated (in %) in Belize and Revenue generated (in %) in Germany?
Your answer should be very brief. 8.46. In the year 2008, what is the difference between the Revenue generated (in %) of Belize and Revenue generated (in %) of India?
Offer a terse response. -19.8. In the year 2008, what is the difference between the Revenue generated (in %) in Germany and Revenue generated (in %) in India?
Provide a short and direct response. -28.26. In the year 2009, what is the difference between the Revenue generated (in %) in Antigua and Barbuda and Revenue generated (in %) in Belize?
Provide a short and direct response. -13.34. In the year 2009, what is the difference between the Revenue generated (in %) in Antigua and Barbuda and Revenue generated (in %) in Germany?
Make the answer very short. 0.89. In the year 2009, what is the difference between the Revenue generated (in %) of Antigua and Barbuda and Revenue generated (in %) of India?
Ensure brevity in your answer.  -33.83. In the year 2009, what is the difference between the Revenue generated (in %) of Belize and Revenue generated (in %) of Germany?
Provide a short and direct response. 14.23. In the year 2009, what is the difference between the Revenue generated (in %) in Belize and Revenue generated (in %) in India?
Keep it short and to the point. -20.48. In the year 2009, what is the difference between the Revenue generated (in %) of Germany and Revenue generated (in %) of India?
Make the answer very short. -34.71. In the year 2010, what is the difference between the Revenue generated (in %) in Antigua and Barbuda and Revenue generated (in %) in Belize?
Provide a succinct answer. -17.35. In the year 2010, what is the difference between the Revenue generated (in %) of Antigua and Barbuda and Revenue generated (in %) of Germany?
Make the answer very short. -1.59. In the year 2010, what is the difference between the Revenue generated (in %) in Antigua and Barbuda and Revenue generated (in %) in India?
Your answer should be compact. -29.89. In the year 2010, what is the difference between the Revenue generated (in %) in Belize and Revenue generated (in %) in Germany?
Your answer should be very brief. 15.76. In the year 2010, what is the difference between the Revenue generated (in %) in Belize and Revenue generated (in %) in India?
Provide a short and direct response. -12.53. In the year 2010, what is the difference between the Revenue generated (in %) of Germany and Revenue generated (in %) of India?
Your answer should be compact. -28.29. In the year 2011, what is the difference between the Revenue generated (in %) of Antigua and Barbuda and Revenue generated (in %) of Belize?
Make the answer very short. -17.16. In the year 2011, what is the difference between the Revenue generated (in %) of Antigua and Barbuda and Revenue generated (in %) of Germany?
Provide a short and direct response. -4.32. In the year 2011, what is the difference between the Revenue generated (in %) of Antigua and Barbuda and Revenue generated (in %) of India?
Offer a terse response. -32.13. In the year 2011, what is the difference between the Revenue generated (in %) in Belize and Revenue generated (in %) in Germany?
Your answer should be very brief. 12.84. In the year 2011, what is the difference between the Revenue generated (in %) in Belize and Revenue generated (in %) in India?
Make the answer very short. -14.97. In the year 2011, what is the difference between the Revenue generated (in %) of Germany and Revenue generated (in %) of India?
Your answer should be very brief. -27.81. In the year 2012, what is the difference between the Revenue generated (in %) in Antigua and Barbuda and Revenue generated (in %) in Belize?
Ensure brevity in your answer.  -16.77. In the year 2012, what is the difference between the Revenue generated (in %) of Antigua and Barbuda and Revenue generated (in %) of Germany?
Your answer should be compact. -4.3. In the year 2012, what is the difference between the Revenue generated (in %) of Antigua and Barbuda and Revenue generated (in %) of India?
Ensure brevity in your answer.  -32.88. In the year 2012, what is the difference between the Revenue generated (in %) of Belize and Revenue generated (in %) of Germany?
Offer a very short reply. 12.47. In the year 2012, what is the difference between the Revenue generated (in %) in Belize and Revenue generated (in %) in India?
Offer a terse response. -16.12. In the year 2012, what is the difference between the Revenue generated (in %) of Germany and Revenue generated (in %) of India?
Your answer should be compact. -28.59. What is the ratio of the Revenue generated (in %) in Antigua and Barbuda in 2005 to that in 2006?
Your response must be concise. 0.37. What is the ratio of the Revenue generated (in %) in Belize in 2005 to that in 2006?
Provide a short and direct response. 1.05. What is the ratio of the Revenue generated (in %) of Germany in 2005 to that in 2006?
Give a very brief answer. 0.93. What is the ratio of the Revenue generated (in %) in India in 2005 to that in 2006?
Keep it short and to the point. 0.91. What is the ratio of the Revenue generated (in %) in Antigua and Barbuda in 2005 to that in 2007?
Your answer should be compact. 0.44. What is the ratio of the Revenue generated (in %) of Belize in 2005 to that in 2007?
Ensure brevity in your answer.  0.95. What is the ratio of the Revenue generated (in %) in Germany in 2005 to that in 2007?
Give a very brief answer. 0.88. What is the ratio of the Revenue generated (in %) in India in 2005 to that in 2007?
Your answer should be very brief. 0.82. What is the ratio of the Revenue generated (in %) of Antigua and Barbuda in 2005 to that in 2008?
Your answer should be compact. 0.41. What is the ratio of the Revenue generated (in %) in Belize in 2005 to that in 2008?
Ensure brevity in your answer.  0.91. What is the ratio of the Revenue generated (in %) of Germany in 2005 to that in 2008?
Offer a terse response. 0.88. What is the ratio of the Revenue generated (in %) of India in 2005 to that in 2008?
Give a very brief answer. 0.79. What is the ratio of the Revenue generated (in %) in Antigua and Barbuda in 2005 to that in 2009?
Your response must be concise. 0.37. What is the ratio of the Revenue generated (in %) of Belize in 2005 to that in 2009?
Offer a very short reply. 0.78. What is the ratio of the Revenue generated (in %) in Germany in 2005 to that in 2009?
Keep it short and to the point. 0.96. What is the ratio of the Revenue generated (in %) of India in 2005 to that in 2009?
Your response must be concise. 0.71. What is the ratio of the Revenue generated (in %) of Antigua and Barbuda in 2005 to that in 2010?
Keep it short and to the point. 0.44. What is the ratio of the Revenue generated (in %) of Belize in 2005 to that in 2010?
Make the answer very short. 0.75. What is the ratio of the Revenue generated (in %) of Germany in 2005 to that in 2010?
Offer a terse response. 0.99. What is the ratio of the Revenue generated (in %) of India in 2005 to that in 2010?
Your response must be concise. 0.83. What is the ratio of the Revenue generated (in %) in Antigua and Barbuda in 2005 to that in 2011?
Give a very brief answer. 0.53. What is the ratio of the Revenue generated (in %) of Belize in 2005 to that in 2011?
Make the answer very short. 0.82. What is the ratio of the Revenue generated (in %) in Germany in 2005 to that in 2011?
Your answer should be very brief. 0.96. What is the ratio of the Revenue generated (in %) of India in 2005 to that in 2011?
Make the answer very short. 0.83. What is the ratio of the Revenue generated (in %) of Antigua and Barbuda in 2005 to that in 2012?
Make the answer very short. 0.5. What is the ratio of the Revenue generated (in %) of Belize in 2005 to that in 2012?
Offer a terse response. 0.81. What is the ratio of the Revenue generated (in %) of Germany in 2005 to that in 2012?
Give a very brief answer. 0.92. What is the ratio of the Revenue generated (in %) in India in 2005 to that in 2012?
Provide a short and direct response. 0.8. What is the ratio of the Revenue generated (in %) of Antigua and Barbuda in 2006 to that in 2007?
Offer a terse response. 1.21. What is the ratio of the Revenue generated (in %) of Belize in 2006 to that in 2007?
Offer a very short reply. 0.91. What is the ratio of the Revenue generated (in %) in Germany in 2006 to that in 2007?
Make the answer very short. 0.95. What is the ratio of the Revenue generated (in %) of India in 2006 to that in 2007?
Provide a short and direct response. 0.9. What is the ratio of the Revenue generated (in %) of Antigua and Barbuda in 2006 to that in 2008?
Your answer should be very brief. 1.13. What is the ratio of the Revenue generated (in %) in Belize in 2006 to that in 2008?
Offer a terse response. 0.87. What is the ratio of the Revenue generated (in %) in Germany in 2006 to that in 2008?
Provide a short and direct response. 0.94. What is the ratio of the Revenue generated (in %) of India in 2006 to that in 2008?
Offer a terse response. 0.87. What is the ratio of the Revenue generated (in %) of Belize in 2006 to that in 2009?
Keep it short and to the point. 0.74. What is the ratio of the Revenue generated (in %) of Germany in 2006 to that in 2009?
Give a very brief answer. 1.03. What is the ratio of the Revenue generated (in %) of India in 2006 to that in 2009?
Provide a short and direct response. 0.79. What is the ratio of the Revenue generated (in %) in Antigua and Barbuda in 2006 to that in 2010?
Make the answer very short. 1.22. What is the ratio of the Revenue generated (in %) in Belize in 2006 to that in 2010?
Provide a succinct answer. 0.72. What is the ratio of the Revenue generated (in %) in Germany in 2006 to that in 2010?
Your answer should be very brief. 1.06. What is the ratio of the Revenue generated (in %) of India in 2006 to that in 2010?
Make the answer very short. 0.91. What is the ratio of the Revenue generated (in %) in Antigua and Barbuda in 2006 to that in 2011?
Your answer should be very brief. 1.46. What is the ratio of the Revenue generated (in %) in Belize in 2006 to that in 2011?
Your response must be concise. 0.78. What is the ratio of the Revenue generated (in %) in Germany in 2006 to that in 2011?
Make the answer very short. 1.03. What is the ratio of the Revenue generated (in %) of India in 2006 to that in 2011?
Provide a short and direct response. 0.91. What is the ratio of the Revenue generated (in %) in Antigua and Barbuda in 2006 to that in 2012?
Your answer should be compact. 1.38. What is the ratio of the Revenue generated (in %) in Belize in 2006 to that in 2012?
Your answer should be compact. 0.77. What is the ratio of the Revenue generated (in %) in Germany in 2006 to that in 2012?
Offer a terse response. 0.99. What is the ratio of the Revenue generated (in %) in India in 2006 to that in 2012?
Your answer should be very brief. 0.88. What is the ratio of the Revenue generated (in %) in Antigua and Barbuda in 2007 to that in 2008?
Provide a succinct answer. 0.93. What is the ratio of the Revenue generated (in %) of Belize in 2007 to that in 2008?
Provide a succinct answer. 0.96. What is the ratio of the Revenue generated (in %) in India in 2007 to that in 2008?
Your response must be concise. 0.97. What is the ratio of the Revenue generated (in %) in Antigua and Barbuda in 2007 to that in 2009?
Make the answer very short. 0.82. What is the ratio of the Revenue generated (in %) in Belize in 2007 to that in 2009?
Ensure brevity in your answer.  0.82. What is the ratio of the Revenue generated (in %) in Germany in 2007 to that in 2009?
Ensure brevity in your answer.  1.08. What is the ratio of the Revenue generated (in %) of India in 2007 to that in 2009?
Give a very brief answer. 0.87. What is the ratio of the Revenue generated (in %) in Belize in 2007 to that in 2010?
Your answer should be very brief. 0.79. What is the ratio of the Revenue generated (in %) in Germany in 2007 to that in 2010?
Your answer should be compact. 1.12. What is the ratio of the Revenue generated (in %) of India in 2007 to that in 2010?
Make the answer very short. 1.01. What is the ratio of the Revenue generated (in %) in Antigua and Barbuda in 2007 to that in 2011?
Your answer should be compact. 1.2. What is the ratio of the Revenue generated (in %) in Belize in 2007 to that in 2011?
Offer a very short reply. 0.86. What is the ratio of the Revenue generated (in %) in Germany in 2007 to that in 2011?
Your answer should be compact. 1.08. What is the ratio of the Revenue generated (in %) in India in 2007 to that in 2011?
Your answer should be compact. 1.01. What is the ratio of the Revenue generated (in %) of Antigua and Barbuda in 2007 to that in 2012?
Ensure brevity in your answer.  1.13. What is the ratio of the Revenue generated (in %) in Belize in 2007 to that in 2012?
Provide a short and direct response. 0.85. What is the ratio of the Revenue generated (in %) of Germany in 2007 to that in 2012?
Make the answer very short. 1.04. What is the ratio of the Revenue generated (in %) of India in 2007 to that in 2012?
Provide a short and direct response. 0.98. What is the ratio of the Revenue generated (in %) in Antigua and Barbuda in 2008 to that in 2009?
Provide a succinct answer. 0.89. What is the ratio of the Revenue generated (in %) of Belize in 2008 to that in 2009?
Provide a succinct answer. 0.85. What is the ratio of the Revenue generated (in %) of Germany in 2008 to that in 2009?
Your answer should be very brief. 1.09. What is the ratio of the Revenue generated (in %) of India in 2008 to that in 2009?
Ensure brevity in your answer.  0.9. What is the ratio of the Revenue generated (in %) of Antigua and Barbuda in 2008 to that in 2010?
Provide a short and direct response. 1.08. What is the ratio of the Revenue generated (in %) of Belize in 2008 to that in 2010?
Your answer should be very brief. 0.82. What is the ratio of the Revenue generated (in %) in Germany in 2008 to that in 2010?
Your answer should be very brief. 1.12. What is the ratio of the Revenue generated (in %) in India in 2008 to that in 2010?
Offer a terse response. 1.04. What is the ratio of the Revenue generated (in %) of Antigua and Barbuda in 2008 to that in 2011?
Keep it short and to the point. 1.29. What is the ratio of the Revenue generated (in %) in Belize in 2008 to that in 2011?
Provide a succinct answer. 0.89. What is the ratio of the Revenue generated (in %) in Germany in 2008 to that in 2011?
Ensure brevity in your answer.  1.09. What is the ratio of the Revenue generated (in %) of India in 2008 to that in 2011?
Provide a succinct answer. 1.04. What is the ratio of the Revenue generated (in %) in Antigua and Barbuda in 2008 to that in 2012?
Keep it short and to the point. 1.22. What is the ratio of the Revenue generated (in %) of Belize in 2008 to that in 2012?
Your answer should be very brief. 0.89. What is the ratio of the Revenue generated (in %) of Germany in 2008 to that in 2012?
Offer a terse response. 1.04. What is the ratio of the Revenue generated (in %) of India in 2008 to that in 2012?
Make the answer very short. 1.01. What is the ratio of the Revenue generated (in %) in Antigua and Barbuda in 2009 to that in 2010?
Your response must be concise. 1.22. What is the ratio of the Revenue generated (in %) in Belize in 2009 to that in 2010?
Your response must be concise. 0.97. What is the ratio of the Revenue generated (in %) in Germany in 2009 to that in 2010?
Make the answer very short. 1.03. What is the ratio of the Revenue generated (in %) in India in 2009 to that in 2010?
Keep it short and to the point. 1.16. What is the ratio of the Revenue generated (in %) of Antigua and Barbuda in 2009 to that in 2011?
Your answer should be compact. 1.46. What is the ratio of the Revenue generated (in %) of Belize in 2009 to that in 2011?
Offer a very short reply. 1.05. What is the ratio of the Revenue generated (in %) in Germany in 2009 to that in 2011?
Make the answer very short. 1. What is the ratio of the Revenue generated (in %) of India in 2009 to that in 2011?
Offer a very short reply. 1.16. What is the ratio of the Revenue generated (in %) in Antigua and Barbuda in 2009 to that in 2012?
Make the answer very short. 1.38. What is the ratio of the Revenue generated (in %) in Belize in 2009 to that in 2012?
Offer a terse response. 1.04. What is the ratio of the Revenue generated (in %) of Germany in 2009 to that in 2012?
Your answer should be compact. 0.96. What is the ratio of the Revenue generated (in %) of India in 2009 to that in 2012?
Offer a terse response. 1.12. What is the ratio of the Revenue generated (in %) of Antigua and Barbuda in 2010 to that in 2011?
Offer a terse response. 1.2. What is the ratio of the Revenue generated (in %) in Belize in 2010 to that in 2011?
Ensure brevity in your answer.  1.09. What is the ratio of the Revenue generated (in %) of Germany in 2010 to that in 2011?
Give a very brief answer. 0.97. What is the ratio of the Revenue generated (in %) of India in 2010 to that in 2011?
Ensure brevity in your answer.  1. What is the ratio of the Revenue generated (in %) in Antigua and Barbuda in 2010 to that in 2012?
Give a very brief answer. 1.13. What is the ratio of the Revenue generated (in %) in Belize in 2010 to that in 2012?
Provide a succinct answer. 1.07. What is the ratio of the Revenue generated (in %) in Germany in 2010 to that in 2012?
Offer a terse response. 0.93. What is the ratio of the Revenue generated (in %) of India in 2010 to that in 2012?
Provide a succinct answer. 0.97. What is the ratio of the Revenue generated (in %) of Antigua and Barbuda in 2011 to that in 2012?
Your response must be concise. 0.94. What is the ratio of the Revenue generated (in %) of Belize in 2011 to that in 2012?
Your answer should be compact. 0.99. What is the ratio of the Revenue generated (in %) in Germany in 2011 to that in 2012?
Keep it short and to the point. 0.96. What is the ratio of the Revenue generated (in %) in India in 2011 to that in 2012?
Your answer should be compact. 0.97. What is the difference between the highest and the second highest Revenue generated (in %) of Antigua and Barbuda?
Your answer should be very brief. 0. What is the difference between the highest and the second highest Revenue generated (in %) in Belize?
Provide a short and direct response. 1.06. What is the difference between the highest and the second highest Revenue generated (in %) in Germany?
Ensure brevity in your answer.  0.12. What is the difference between the highest and the second highest Revenue generated (in %) in India?
Offer a terse response. 5.04. What is the difference between the highest and the lowest Revenue generated (in %) of Antigua and Barbuda?
Give a very brief answer. 10.44. What is the difference between the highest and the lowest Revenue generated (in %) of Belize?
Provide a succinct answer. 8.68. What is the difference between the highest and the lowest Revenue generated (in %) of Germany?
Your answer should be very brief. 2.08. What is the difference between the highest and the lowest Revenue generated (in %) of India?
Provide a short and direct response. 14.34. 